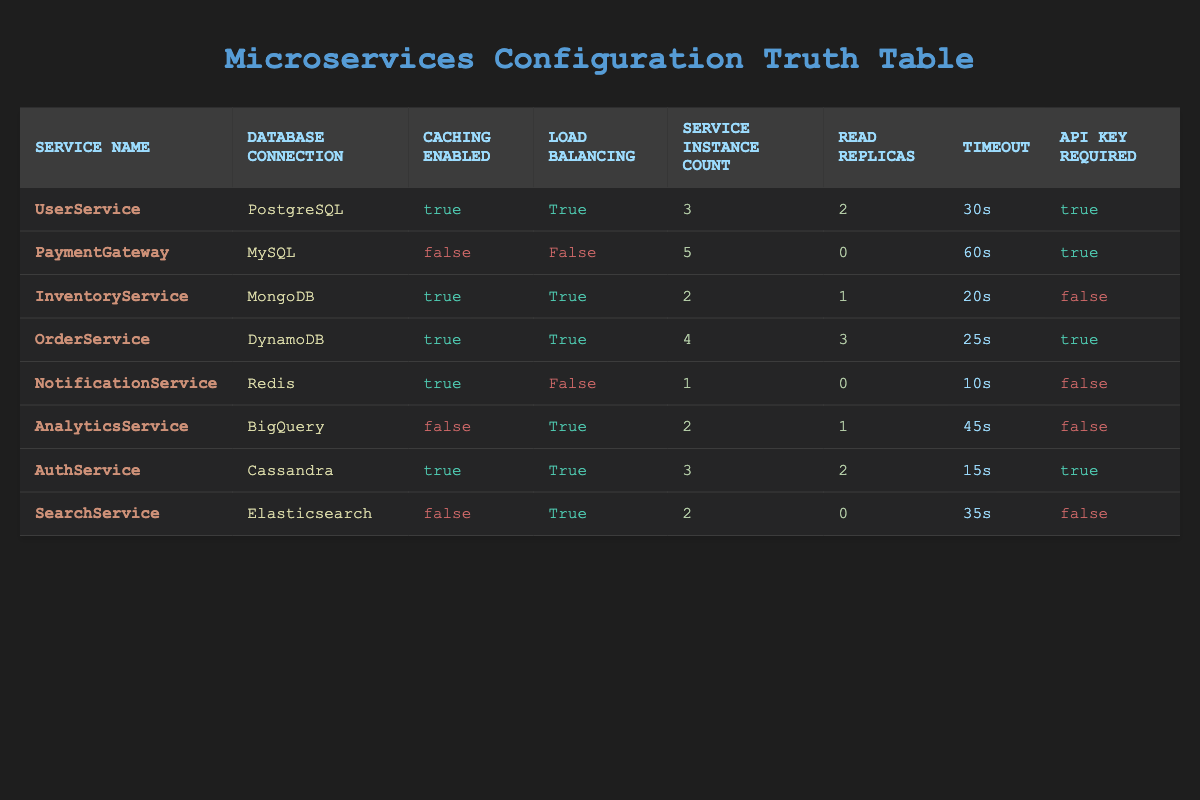What database does UserService use? According to the table, the Database Connection for UserService is listed as PostgreSQL. Simply read the corresponding cell under the Database Connection column for the UserService row.
Answer: PostgreSQL How many instances does the PaymentGateway service run? The Service Instance Count for PaymentGateway is shown as 5 in the table. By checking the corresponding cell under the Service Instance Count column for the PaymentGateway row, we can find this value.
Answer: 5 Do any services have caching disabled? Yes, both PaymentGateway and AnalyticsService have Caching Enabled marked as false. By scanning the Caching Enabled column, the values marked false confirm that these services do not use caching.
Answer: Yes What is the total number of Read Replicas across all services? To find the total, add the Read Replicas for each service: 2 + 0 + 1 + 3 + 0 + 1 + 2 + 0 = 9. This requires us to sum the values in the Read Replicas column. The final total is 9.
Answer: 9 Which service has the lowest timeout? The lowest Timeout is associated with NotificationService, which is 10 seconds. Comparing all the values in the Timeout column shows that 10s is the smallest value.
Answer: NotificationService Is Load Balancing enabled for all services? No, Load Balancing is disabled for PaymentGateway and NotificationService, as indicated by the values marked false in the Load Balancing column for these rows.
Answer: No How many services require an API key? There are four services that require an API key, specifically UserService, PaymentGateway, OrderService, and AuthService. Counting the occurrences of true in the API Key Required column provides this total.
Answer: 4 Which database connections are used by services that do not enable caching? The services that do not enable caching are PaymentGateway and AnalyticsService, which use MySQL and BigQuery respectively. By locating the rows with Caching Enabled as false, we can see these associated database connections.
Answer: MySQL and BigQuery What is the average Service Instance Count for services with Load Balancing enabled? The services with Load Balancing enabled are UserService (3), InventoryService (2), OrderService (4), AnalyticsService (2), AuthService (3), and SearchService (2). Adding these values gives 16, and there are 6 services, so the average is calculated as 16/6, which results in approximately 2.67.
Answer: Approximately 2.67 